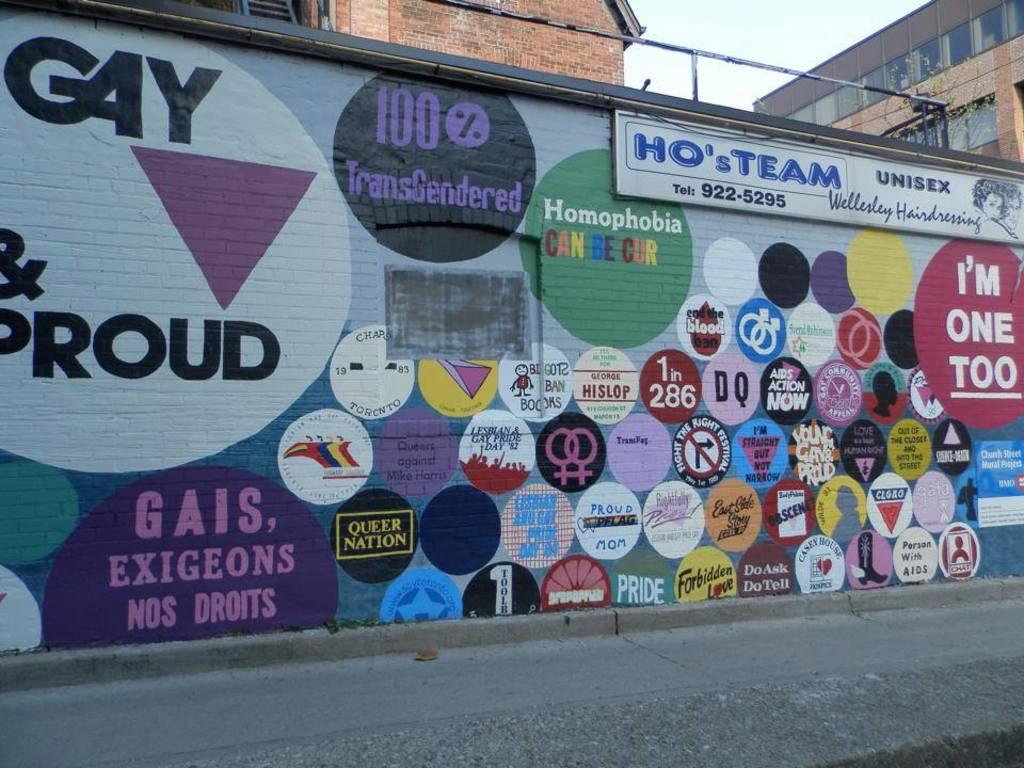What is wrote on the top left above the triangle?
Your response must be concise. Gay. 